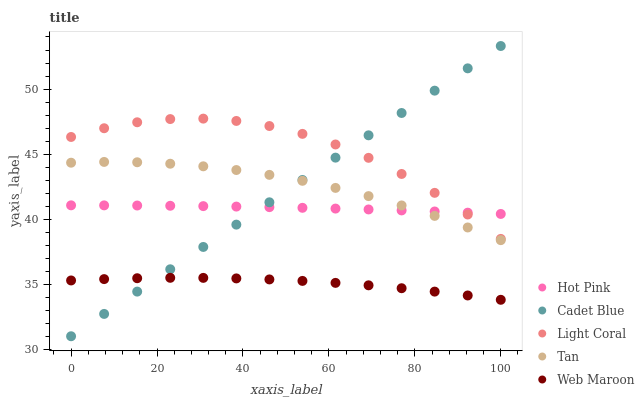Does Web Maroon have the minimum area under the curve?
Answer yes or no. Yes. Does Light Coral have the maximum area under the curve?
Answer yes or no. Yes. Does Tan have the minimum area under the curve?
Answer yes or no. No. Does Tan have the maximum area under the curve?
Answer yes or no. No. Is Cadet Blue the smoothest?
Answer yes or no. Yes. Is Light Coral the roughest?
Answer yes or no. Yes. Is Tan the smoothest?
Answer yes or no. No. Is Tan the roughest?
Answer yes or no. No. Does Cadet Blue have the lowest value?
Answer yes or no. Yes. Does Light Coral have the lowest value?
Answer yes or no. No. Does Cadet Blue have the highest value?
Answer yes or no. Yes. Does Light Coral have the highest value?
Answer yes or no. No. Is Web Maroon less than Hot Pink?
Answer yes or no. Yes. Is Hot Pink greater than Web Maroon?
Answer yes or no. Yes. Does Hot Pink intersect Tan?
Answer yes or no. Yes. Is Hot Pink less than Tan?
Answer yes or no. No. Is Hot Pink greater than Tan?
Answer yes or no. No. Does Web Maroon intersect Hot Pink?
Answer yes or no. No. 